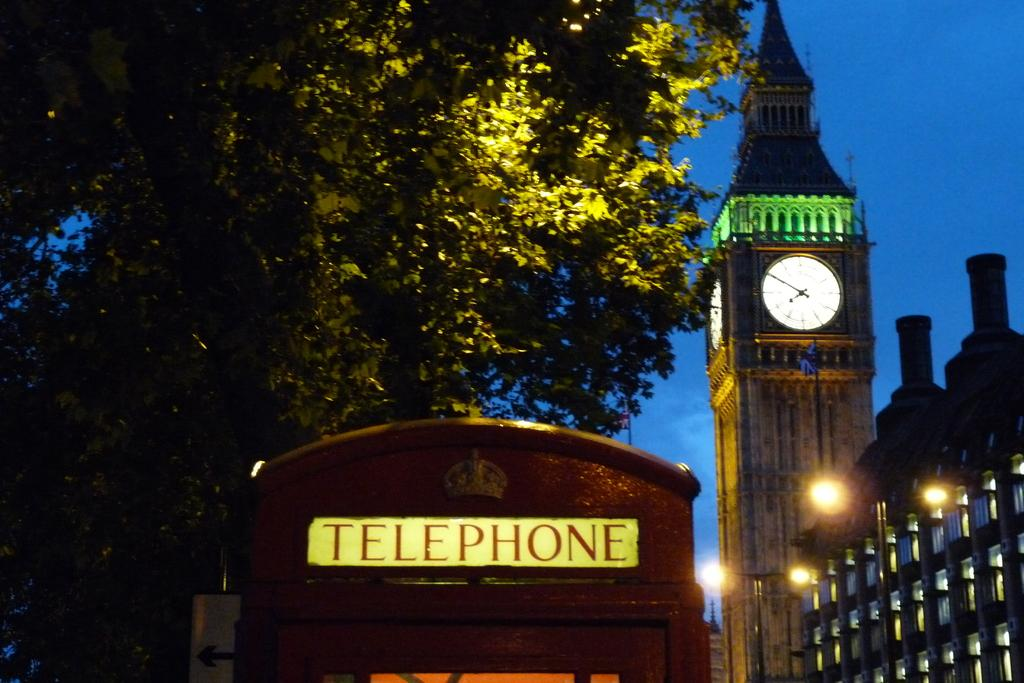<image>
Summarize the visual content of the image. Red phone booth that says "Telephone" on it. 